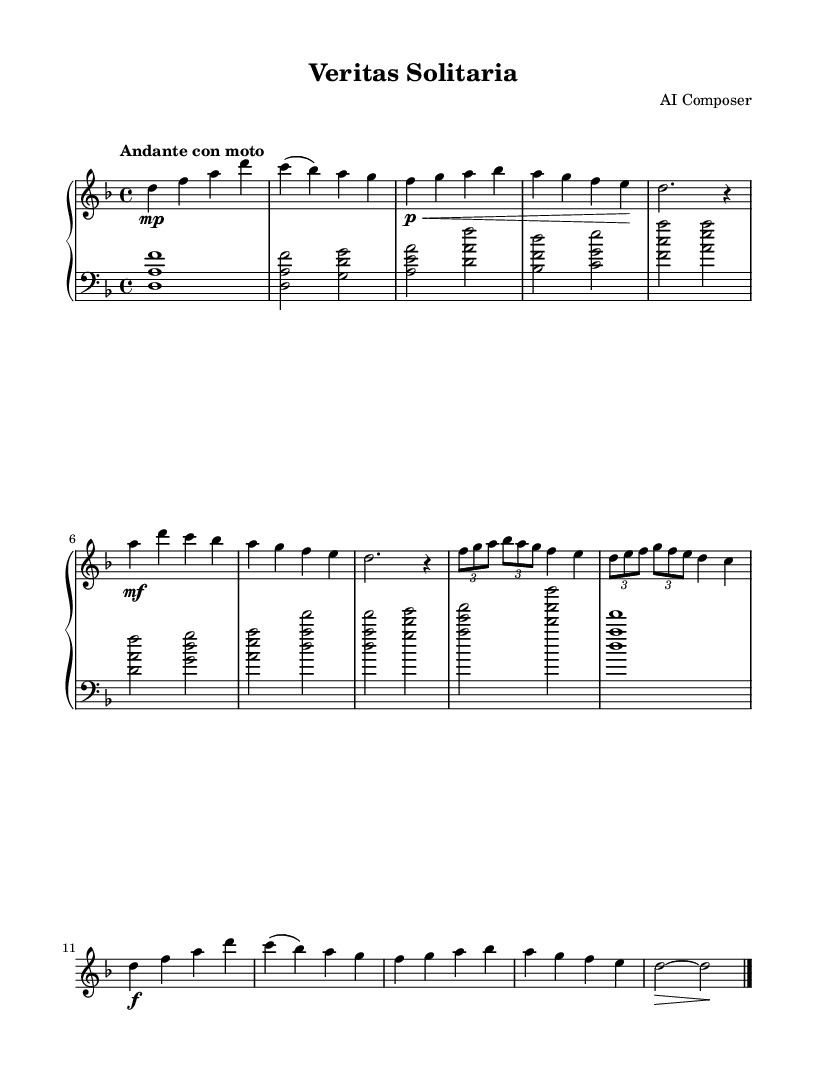What is the key signature of this music? The key signature is D minor, which contains one flat (B flat).
Answer: D minor What is the time signature? The time signature is 4/4, indicating there are four beats in each measure.
Answer: 4/4 What is the tempo marking? The tempo marking is "Andante con moto," which suggests a moderately slow tempo with some motion.
Answer: Andante con moto How many themes are present in this composition? There are two distinct themes present (Theme A and Theme B).
Answer: Two In which section does the development occur? The development occurs after the initial presentation of themes, specifically labeled as "Development" in the music.
Answer: Development What dynamic marking is found at the beginning of Theme A? The dynamic marking at the beginning of Theme A is piano (p), indicating a soft sound.
Answer: piano What is the last musical instruction before the coda? The last musical instruction before the coda is a fermata, indicating to hold the note longer.
Answer: fermata 